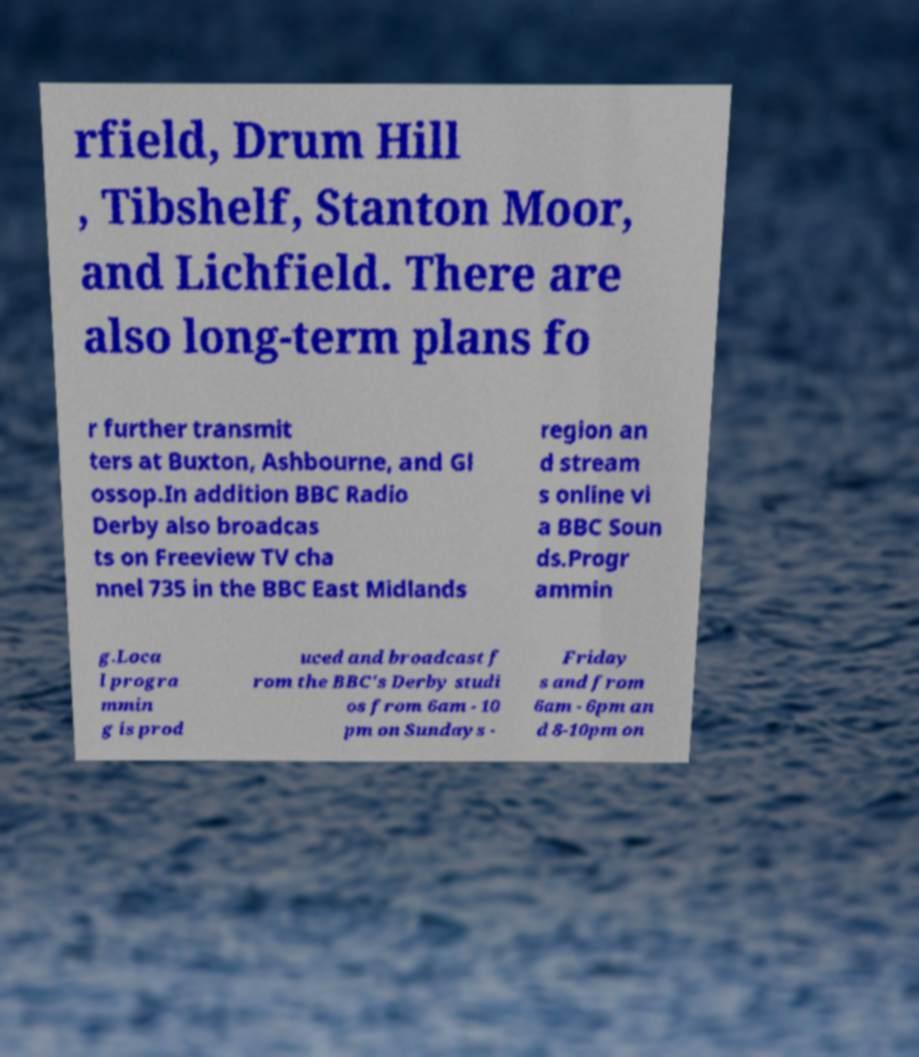There's text embedded in this image that I need extracted. Can you transcribe it verbatim? rfield, Drum Hill , Tibshelf, Stanton Moor, and Lichfield. There are also long-term plans fo r further transmit ters at Buxton, Ashbourne, and Gl ossop.In addition BBC Radio Derby also broadcas ts on Freeview TV cha nnel 735 in the BBC East Midlands region an d stream s online vi a BBC Soun ds.Progr ammin g.Loca l progra mmin g is prod uced and broadcast f rom the BBC's Derby studi os from 6am - 10 pm on Sundays - Friday s and from 6am - 6pm an d 8-10pm on 